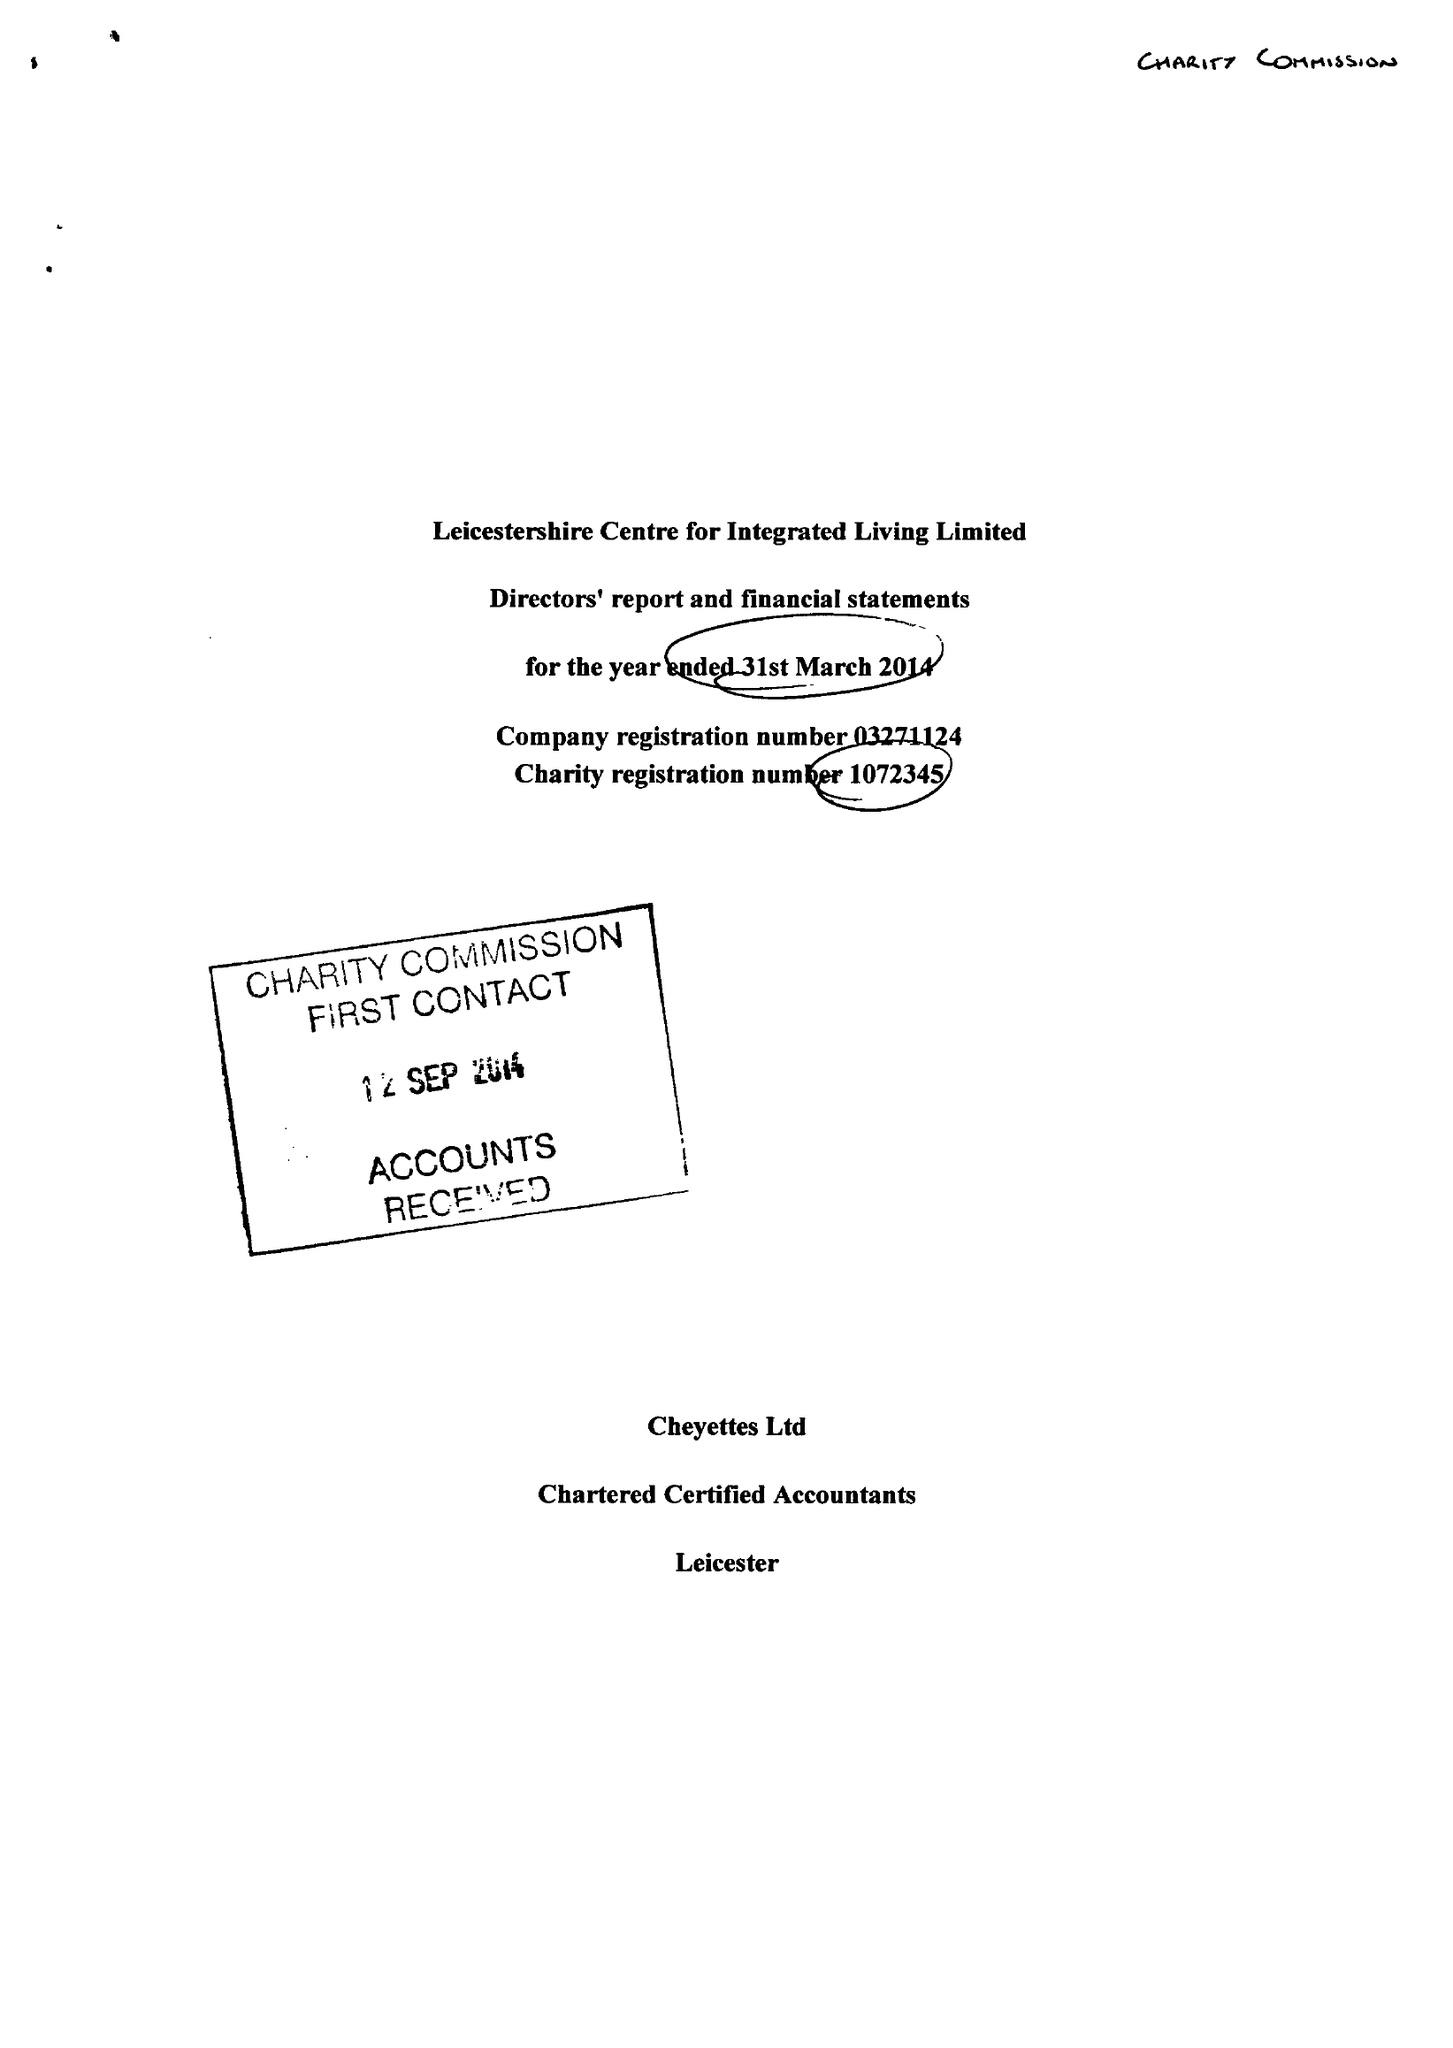What is the value for the address__post_town?
Answer the question using a single word or phrase. LEICESTER 